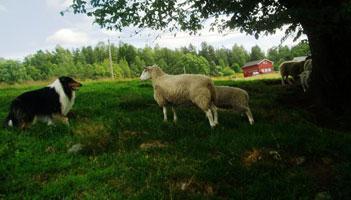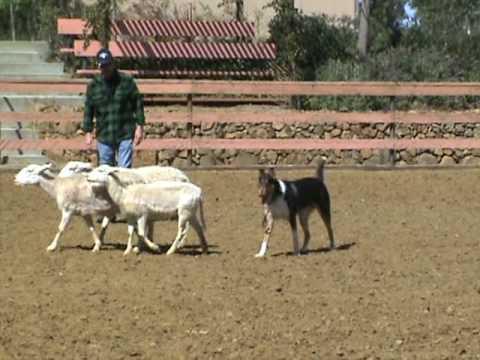The first image is the image on the left, the second image is the image on the right. Considering the images on both sides, is "An image shows a dog behind three sheep which are moving leftward." valid? Answer yes or no. Yes. The first image is the image on the left, the second image is the image on the right. Analyze the images presented: Is the assertion "A person is standing by a wooden fence with some animals in a field in one of the images." valid? Answer yes or no. Yes. 